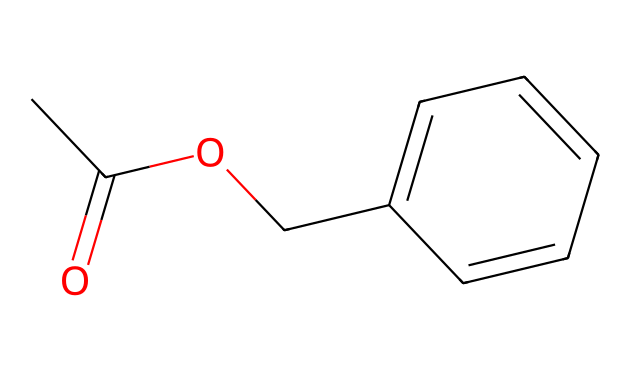What is the name of this chemical? The SMILES representation CC(=O)OCc1ccccc1 corresponds to benzyl acetate, which is characterized by its acetate group (CC(=O)O) and a benzyl group (Cc1ccccc1).
Answer: benzyl acetate How many carbon atoms are in benzyl acetate? Looking at the SMILES representation, there are a total of 9 carbon atoms: 2 from the acetate group and 7 from the benzyl group.
Answer: 9 What functional group is present in this chemical? The presence of the -COO- segment (from the acetate group) indicates that benzyl acetate contains an ester functional group, characteristic in esters.
Answer: ester What type of bonding is primarily found in benzyl acetate? The bonding in benzyl acetate is primarily covalent, as it consists of covalent bonds between carbon, hydrogen, and oxygen atoms, which is typical for organic compounds.
Answer: covalent Is benzyl acetate a solid, liquid, or gas at room temperature? Benzyl acetate is a liquid at room temperature, as indicated by its use in perfumes and body sprays, which are typically liquid mixtures.
Answer: liquid What characteristic scent is associated with benzyl acetate? Benzyl acetate is known for its jasmine-like scent, which is often used in fragrances due to this floral aroma.
Answer: jasmine-like scent What is the molecular formula of benzyl acetate? By analyzing the elements in the SMILES representation, we can derive the molecular formula C9H10O2, counting all carbons, hydrogens, and oxygens present.
Answer: C9H10O2 